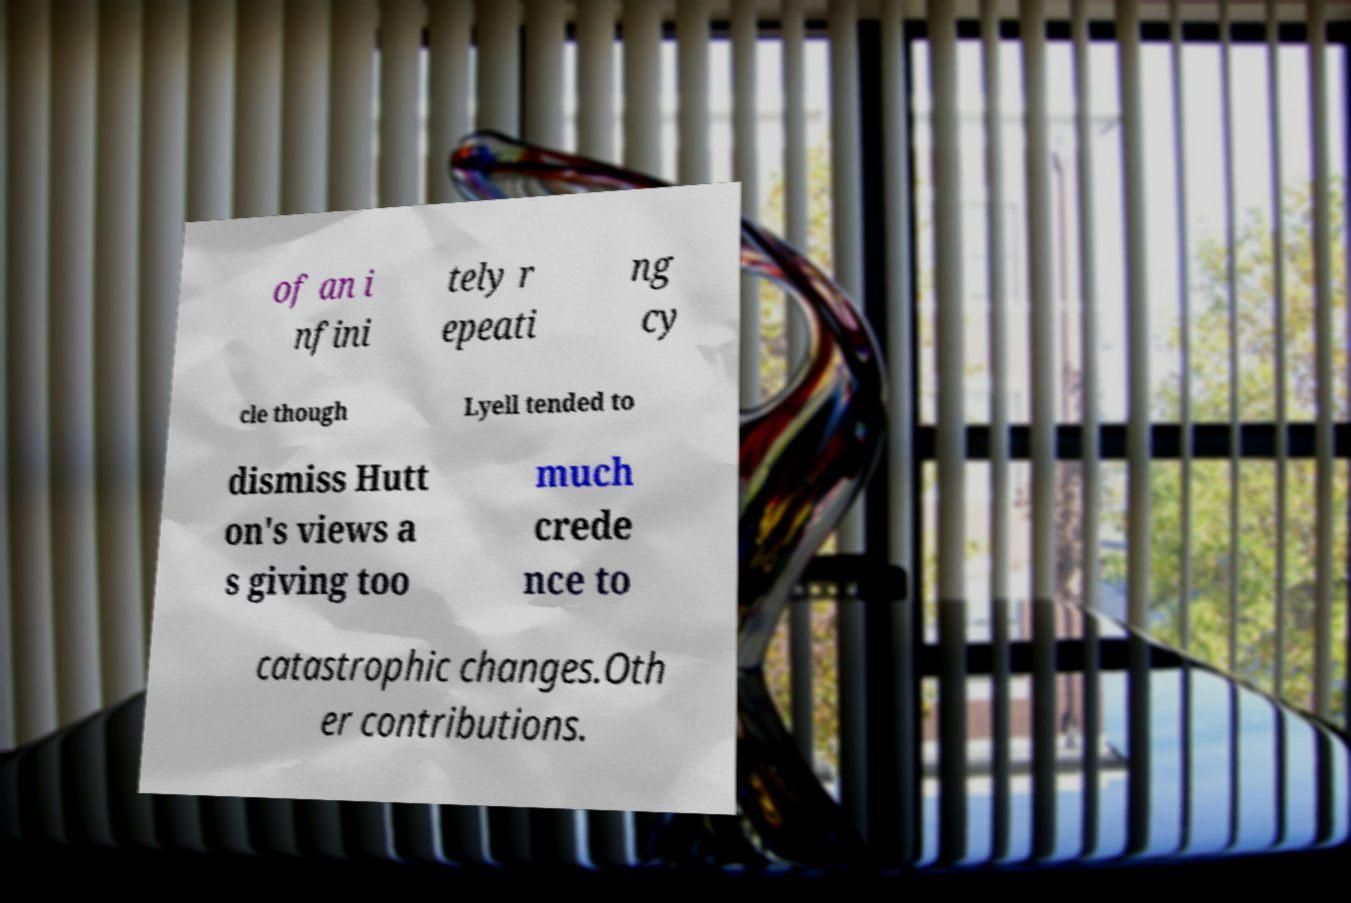For documentation purposes, I need the text within this image transcribed. Could you provide that? of an i nfini tely r epeati ng cy cle though Lyell tended to dismiss Hutt on's views a s giving too much crede nce to catastrophic changes.Oth er contributions. 